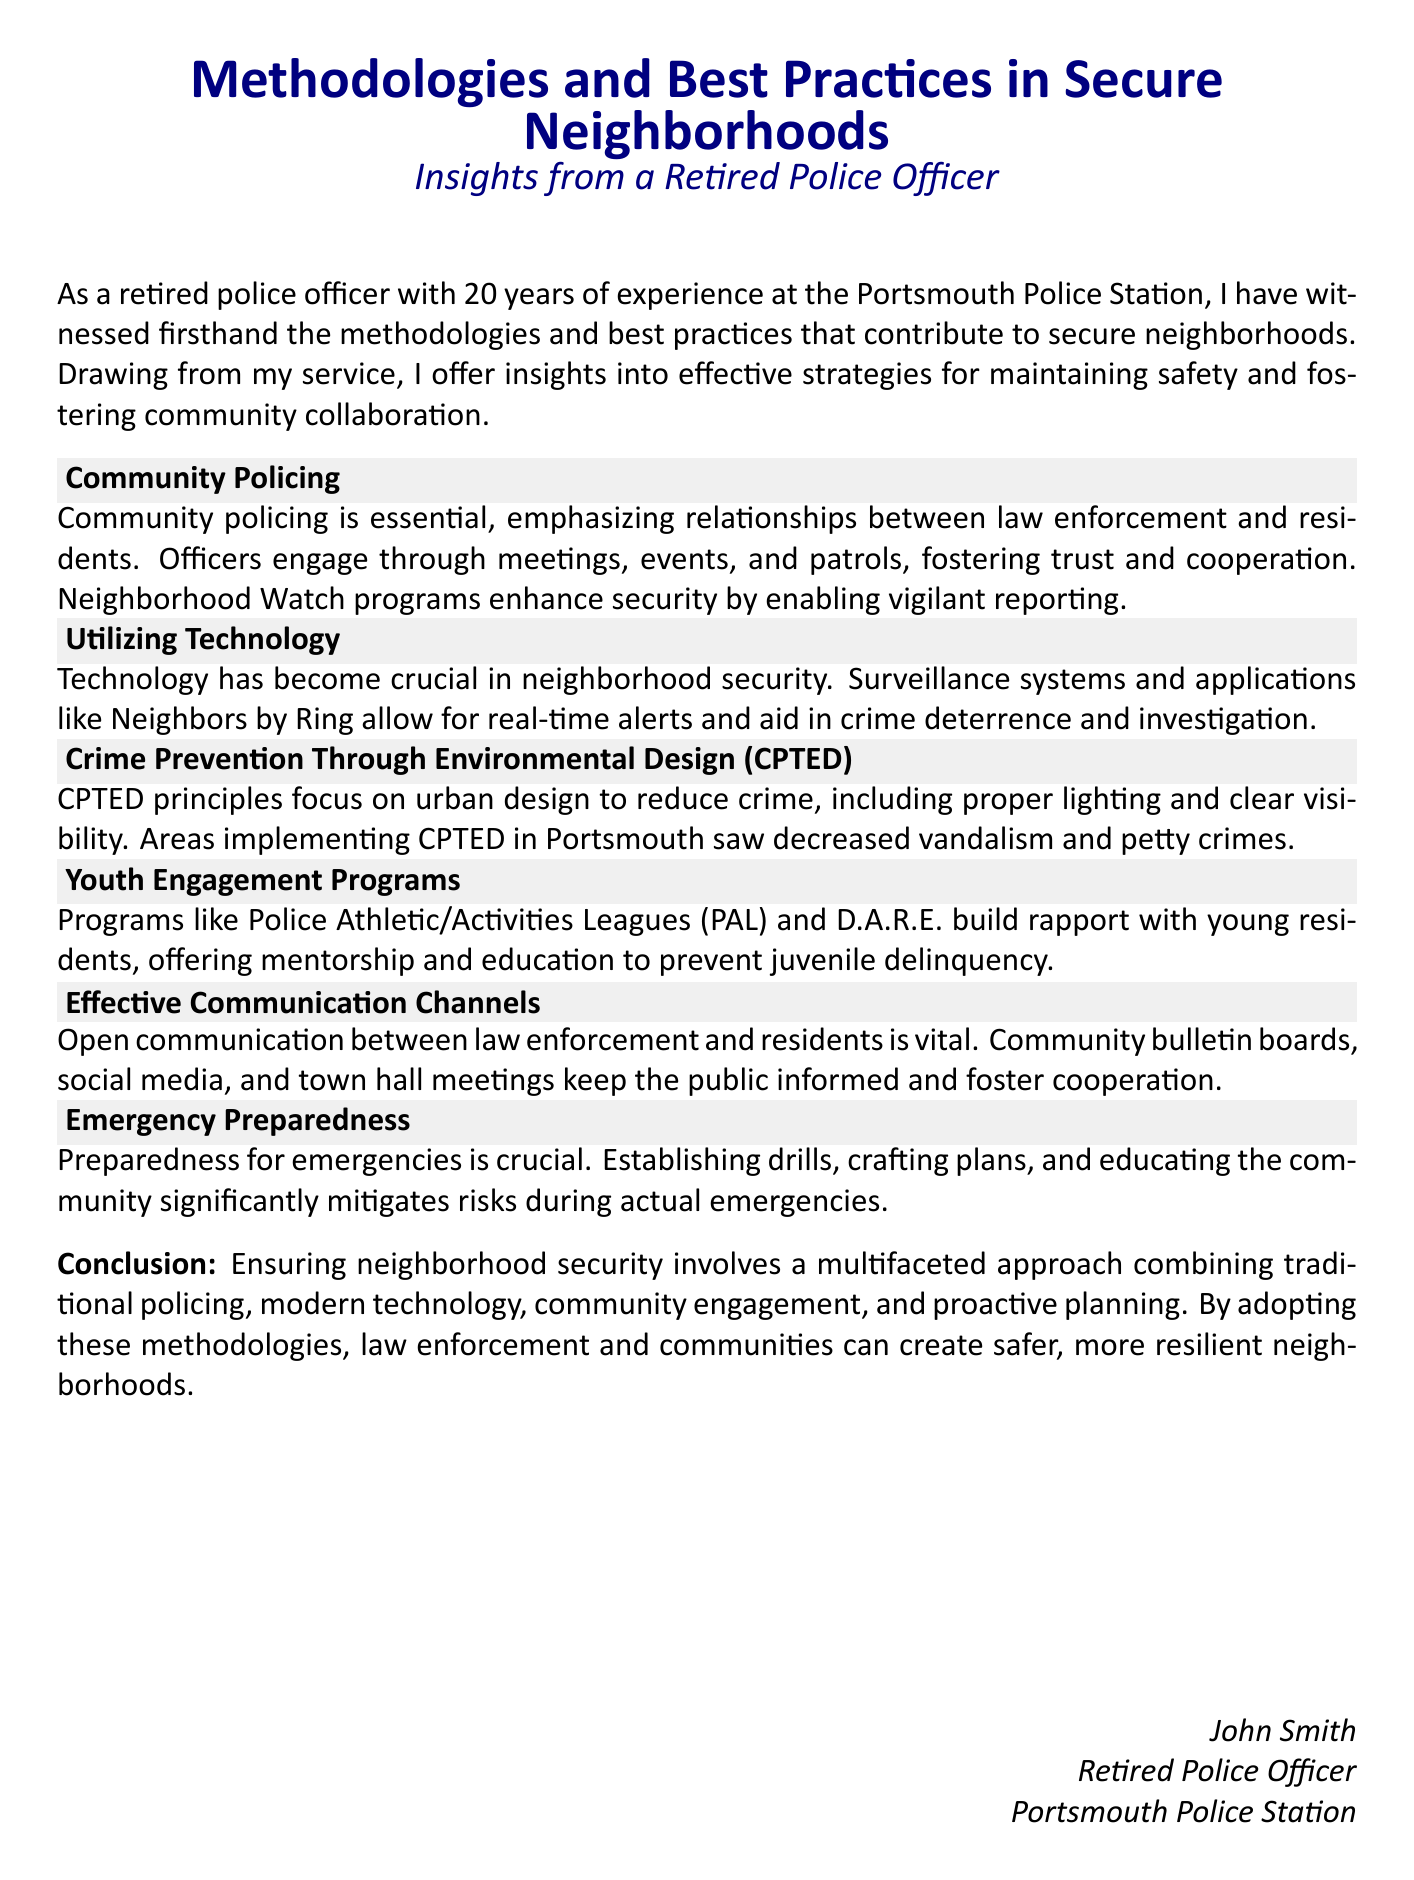What is the title of the document? The title is presented at the beginning of the document, indicating the subject of focus.
Answer: Methodologies and Best Practices in Secure Neighborhoods Who is the author of the document? The author is credited at the end of the document, indicating his background and experience.
Answer: John Smith How many years of service did the author have? The document mentions the author's tenure in law enforcement, providing a specific duration of service.
Answer: 20 years What is the main focus of Community Policing? The section describes the primary goal of community policing, which is to enhance relationships within the community.
Answer: Relationships between law enforcement and residents What does CPTED stand for? The acronym is defined in the document as it relates to crime prevention strategies.
Answer: Crime Prevention Through Environmental Design What technology is mentioned for neighborhood security? The document lists specific technological tools that assist in community safety.
Answer: Neighbors by Ring What are Youth Engagement Programs aimed at? The document explains the purpose of these programs in the context of community safety for the youth.
Answer: Prevent juvenile delinquency What is essential for effective communication according to the document? The document emphasizes a specific aspect of communication that is crucial for cooperation.
Answer: Open communication What is the concluding message of the document? The conclusion summarizes the overall approach to achieving neighborhood security.
Answer: Multifaceted approach combining traditional policing, modern technology, community engagement, and proactive planning 